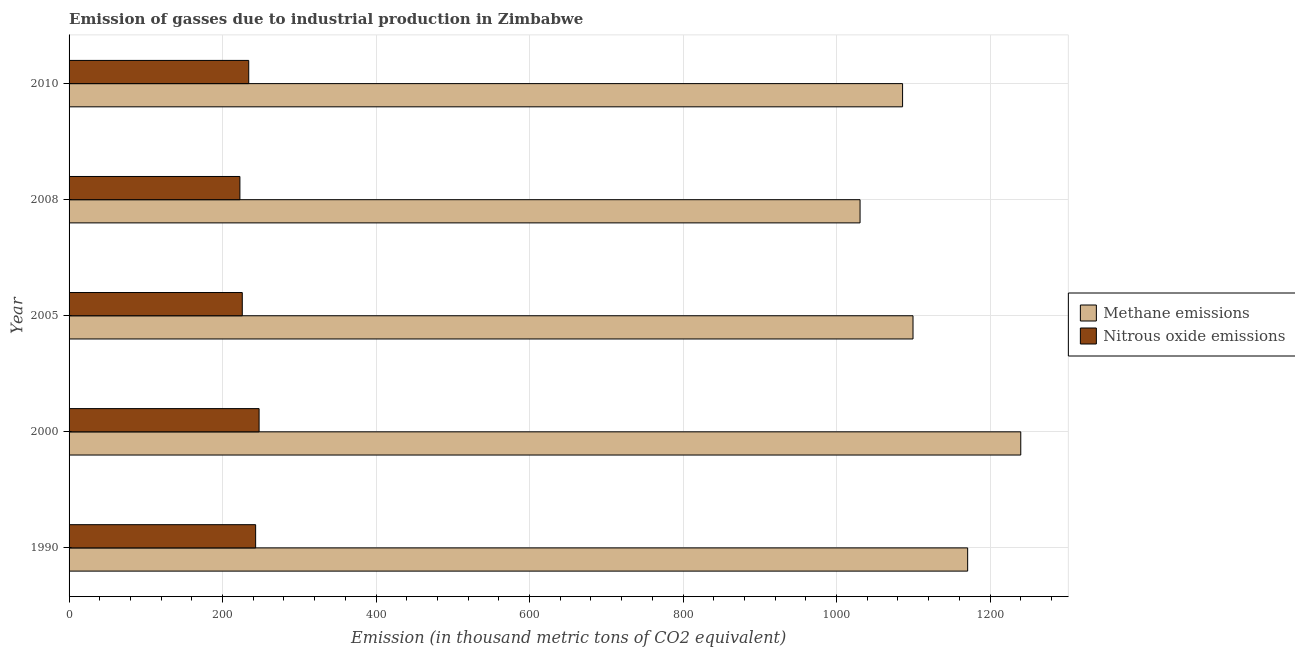How many groups of bars are there?
Keep it short and to the point. 5. Are the number of bars per tick equal to the number of legend labels?
Provide a succinct answer. Yes. Are the number of bars on each tick of the Y-axis equal?
Your answer should be very brief. Yes. What is the amount of methane emissions in 2010?
Your response must be concise. 1086.1. Across all years, what is the maximum amount of methane emissions?
Ensure brevity in your answer.  1240.1. Across all years, what is the minimum amount of nitrous oxide emissions?
Ensure brevity in your answer.  222.6. In which year was the amount of nitrous oxide emissions minimum?
Keep it short and to the point. 2008. What is the total amount of nitrous oxide emissions in the graph?
Provide a succinct answer. 1173.1. What is the difference between the amount of nitrous oxide emissions in 2008 and the amount of methane emissions in 1990?
Offer a terse response. -948.3. What is the average amount of methane emissions per year?
Provide a succinct answer. 1125.5. In the year 2005, what is the difference between the amount of nitrous oxide emissions and amount of methane emissions?
Provide a short and direct response. -874. What is the ratio of the amount of nitrous oxide emissions in 1990 to that in 2010?
Provide a short and direct response. 1.04. Is the amount of methane emissions in 2005 less than that in 2010?
Provide a succinct answer. No. What is the difference between the highest and the second highest amount of methane emissions?
Keep it short and to the point. 69.2. What is the difference between the highest and the lowest amount of nitrous oxide emissions?
Offer a terse response. 25. In how many years, is the amount of nitrous oxide emissions greater than the average amount of nitrous oxide emissions taken over all years?
Your answer should be compact. 2. What does the 2nd bar from the top in 2008 represents?
Ensure brevity in your answer.  Methane emissions. What does the 2nd bar from the bottom in 2005 represents?
Your response must be concise. Nitrous oxide emissions. How many bars are there?
Provide a short and direct response. 10. What is the difference between two consecutive major ticks on the X-axis?
Provide a short and direct response. 200. Are the values on the major ticks of X-axis written in scientific E-notation?
Offer a terse response. No. Does the graph contain grids?
Offer a very short reply. Yes. Where does the legend appear in the graph?
Offer a very short reply. Center right. How many legend labels are there?
Keep it short and to the point. 2. What is the title of the graph?
Your answer should be very brief. Emission of gasses due to industrial production in Zimbabwe. Does "Tetanus" appear as one of the legend labels in the graph?
Make the answer very short. No. What is the label or title of the X-axis?
Ensure brevity in your answer.  Emission (in thousand metric tons of CO2 equivalent). What is the Emission (in thousand metric tons of CO2 equivalent) of Methane emissions in 1990?
Your response must be concise. 1170.9. What is the Emission (in thousand metric tons of CO2 equivalent) in Nitrous oxide emissions in 1990?
Offer a terse response. 243.1. What is the Emission (in thousand metric tons of CO2 equivalent) in Methane emissions in 2000?
Offer a terse response. 1240.1. What is the Emission (in thousand metric tons of CO2 equivalent) in Nitrous oxide emissions in 2000?
Your answer should be compact. 247.6. What is the Emission (in thousand metric tons of CO2 equivalent) of Methane emissions in 2005?
Make the answer very short. 1099.7. What is the Emission (in thousand metric tons of CO2 equivalent) in Nitrous oxide emissions in 2005?
Ensure brevity in your answer.  225.7. What is the Emission (in thousand metric tons of CO2 equivalent) in Methane emissions in 2008?
Offer a terse response. 1030.7. What is the Emission (in thousand metric tons of CO2 equivalent) in Nitrous oxide emissions in 2008?
Your answer should be compact. 222.6. What is the Emission (in thousand metric tons of CO2 equivalent) of Methane emissions in 2010?
Your answer should be compact. 1086.1. What is the Emission (in thousand metric tons of CO2 equivalent) of Nitrous oxide emissions in 2010?
Your answer should be very brief. 234.1. Across all years, what is the maximum Emission (in thousand metric tons of CO2 equivalent) of Methane emissions?
Offer a terse response. 1240.1. Across all years, what is the maximum Emission (in thousand metric tons of CO2 equivalent) in Nitrous oxide emissions?
Give a very brief answer. 247.6. Across all years, what is the minimum Emission (in thousand metric tons of CO2 equivalent) in Methane emissions?
Offer a very short reply. 1030.7. Across all years, what is the minimum Emission (in thousand metric tons of CO2 equivalent) of Nitrous oxide emissions?
Offer a terse response. 222.6. What is the total Emission (in thousand metric tons of CO2 equivalent) of Methane emissions in the graph?
Offer a terse response. 5627.5. What is the total Emission (in thousand metric tons of CO2 equivalent) in Nitrous oxide emissions in the graph?
Ensure brevity in your answer.  1173.1. What is the difference between the Emission (in thousand metric tons of CO2 equivalent) in Methane emissions in 1990 and that in 2000?
Your response must be concise. -69.2. What is the difference between the Emission (in thousand metric tons of CO2 equivalent) in Nitrous oxide emissions in 1990 and that in 2000?
Make the answer very short. -4.5. What is the difference between the Emission (in thousand metric tons of CO2 equivalent) of Methane emissions in 1990 and that in 2005?
Offer a very short reply. 71.2. What is the difference between the Emission (in thousand metric tons of CO2 equivalent) in Nitrous oxide emissions in 1990 and that in 2005?
Offer a terse response. 17.4. What is the difference between the Emission (in thousand metric tons of CO2 equivalent) of Methane emissions in 1990 and that in 2008?
Provide a succinct answer. 140.2. What is the difference between the Emission (in thousand metric tons of CO2 equivalent) in Methane emissions in 1990 and that in 2010?
Provide a succinct answer. 84.8. What is the difference between the Emission (in thousand metric tons of CO2 equivalent) in Methane emissions in 2000 and that in 2005?
Your answer should be very brief. 140.4. What is the difference between the Emission (in thousand metric tons of CO2 equivalent) in Nitrous oxide emissions in 2000 and that in 2005?
Keep it short and to the point. 21.9. What is the difference between the Emission (in thousand metric tons of CO2 equivalent) of Methane emissions in 2000 and that in 2008?
Your response must be concise. 209.4. What is the difference between the Emission (in thousand metric tons of CO2 equivalent) in Methane emissions in 2000 and that in 2010?
Your answer should be very brief. 154. What is the difference between the Emission (in thousand metric tons of CO2 equivalent) in Nitrous oxide emissions in 2005 and that in 2008?
Keep it short and to the point. 3.1. What is the difference between the Emission (in thousand metric tons of CO2 equivalent) of Methane emissions in 2008 and that in 2010?
Offer a terse response. -55.4. What is the difference between the Emission (in thousand metric tons of CO2 equivalent) of Nitrous oxide emissions in 2008 and that in 2010?
Make the answer very short. -11.5. What is the difference between the Emission (in thousand metric tons of CO2 equivalent) in Methane emissions in 1990 and the Emission (in thousand metric tons of CO2 equivalent) in Nitrous oxide emissions in 2000?
Give a very brief answer. 923.3. What is the difference between the Emission (in thousand metric tons of CO2 equivalent) in Methane emissions in 1990 and the Emission (in thousand metric tons of CO2 equivalent) in Nitrous oxide emissions in 2005?
Ensure brevity in your answer.  945.2. What is the difference between the Emission (in thousand metric tons of CO2 equivalent) of Methane emissions in 1990 and the Emission (in thousand metric tons of CO2 equivalent) of Nitrous oxide emissions in 2008?
Offer a very short reply. 948.3. What is the difference between the Emission (in thousand metric tons of CO2 equivalent) in Methane emissions in 1990 and the Emission (in thousand metric tons of CO2 equivalent) in Nitrous oxide emissions in 2010?
Your answer should be compact. 936.8. What is the difference between the Emission (in thousand metric tons of CO2 equivalent) in Methane emissions in 2000 and the Emission (in thousand metric tons of CO2 equivalent) in Nitrous oxide emissions in 2005?
Give a very brief answer. 1014.4. What is the difference between the Emission (in thousand metric tons of CO2 equivalent) in Methane emissions in 2000 and the Emission (in thousand metric tons of CO2 equivalent) in Nitrous oxide emissions in 2008?
Ensure brevity in your answer.  1017.5. What is the difference between the Emission (in thousand metric tons of CO2 equivalent) in Methane emissions in 2000 and the Emission (in thousand metric tons of CO2 equivalent) in Nitrous oxide emissions in 2010?
Your response must be concise. 1006. What is the difference between the Emission (in thousand metric tons of CO2 equivalent) in Methane emissions in 2005 and the Emission (in thousand metric tons of CO2 equivalent) in Nitrous oxide emissions in 2008?
Provide a succinct answer. 877.1. What is the difference between the Emission (in thousand metric tons of CO2 equivalent) in Methane emissions in 2005 and the Emission (in thousand metric tons of CO2 equivalent) in Nitrous oxide emissions in 2010?
Provide a succinct answer. 865.6. What is the difference between the Emission (in thousand metric tons of CO2 equivalent) of Methane emissions in 2008 and the Emission (in thousand metric tons of CO2 equivalent) of Nitrous oxide emissions in 2010?
Keep it short and to the point. 796.6. What is the average Emission (in thousand metric tons of CO2 equivalent) of Methane emissions per year?
Give a very brief answer. 1125.5. What is the average Emission (in thousand metric tons of CO2 equivalent) of Nitrous oxide emissions per year?
Offer a very short reply. 234.62. In the year 1990, what is the difference between the Emission (in thousand metric tons of CO2 equivalent) of Methane emissions and Emission (in thousand metric tons of CO2 equivalent) of Nitrous oxide emissions?
Your answer should be very brief. 927.8. In the year 2000, what is the difference between the Emission (in thousand metric tons of CO2 equivalent) in Methane emissions and Emission (in thousand metric tons of CO2 equivalent) in Nitrous oxide emissions?
Provide a short and direct response. 992.5. In the year 2005, what is the difference between the Emission (in thousand metric tons of CO2 equivalent) in Methane emissions and Emission (in thousand metric tons of CO2 equivalent) in Nitrous oxide emissions?
Make the answer very short. 874. In the year 2008, what is the difference between the Emission (in thousand metric tons of CO2 equivalent) of Methane emissions and Emission (in thousand metric tons of CO2 equivalent) of Nitrous oxide emissions?
Your answer should be very brief. 808.1. In the year 2010, what is the difference between the Emission (in thousand metric tons of CO2 equivalent) in Methane emissions and Emission (in thousand metric tons of CO2 equivalent) in Nitrous oxide emissions?
Your answer should be very brief. 852. What is the ratio of the Emission (in thousand metric tons of CO2 equivalent) in Methane emissions in 1990 to that in 2000?
Ensure brevity in your answer.  0.94. What is the ratio of the Emission (in thousand metric tons of CO2 equivalent) of Nitrous oxide emissions in 1990 to that in 2000?
Offer a very short reply. 0.98. What is the ratio of the Emission (in thousand metric tons of CO2 equivalent) in Methane emissions in 1990 to that in 2005?
Keep it short and to the point. 1.06. What is the ratio of the Emission (in thousand metric tons of CO2 equivalent) of Nitrous oxide emissions in 1990 to that in 2005?
Provide a short and direct response. 1.08. What is the ratio of the Emission (in thousand metric tons of CO2 equivalent) of Methane emissions in 1990 to that in 2008?
Provide a short and direct response. 1.14. What is the ratio of the Emission (in thousand metric tons of CO2 equivalent) of Nitrous oxide emissions in 1990 to that in 2008?
Your answer should be very brief. 1.09. What is the ratio of the Emission (in thousand metric tons of CO2 equivalent) in Methane emissions in 1990 to that in 2010?
Keep it short and to the point. 1.08. What is the ratio of the Emission (in thousand metric tons of CO2 equivalent) in Nitrous oxide emissions in 1990 to that in 2010?
Ensure brevity in your answer.  1.04. What is the ratio of the Emission (in thousand metric tons of CO2 equivalent) in Methane emissions in 2000 to that in 2005?
Your answer should be compact. 1.13. What is the ratio of the Emission (in thousand metric tons of CO2 equivalent) in Nitrous oxide emissions in 2000 to that in 2005?
Your answer should be compact. 1.1. What is the ratio of the Emission (in thousand metric tons of CO2 equivalent) in Methane emissions in 2000 to that in 2008?
Your answer should be very brief. 1.2. What is the ratio of the Emission (in thousand metric tons of CO2 equivalent) of Nitrous oxide emissions in 2000 to that in 2008?
Your answer should be very brief. 1.11. What is the ratio of the Emission (in thousand metric tons of CO2 equivalent) in Methane emissions in 2000 to that in 2010?
Your answer should be very brief. 1.14. What is the ratio of the Emission (in thousand metric tons of CO2 equivalent) of Nitrous oxide emissions in 2000 to that in 2010?
Offer a very short reply. 1.06. What is the ratio of the Emission (in thousand metric tons of CO2 equivalent) in Methane emissions in 2005 to that in 2008?
Ensure brevity in your answer.  1.07. What is the ratio of the Emission (in thousand metric tons of CO2 equivalent) of Nitrous oxide emissions in 2005 to that in 2008?
Your answer should be very brief. 1.01. What is the ratio of the Emission (in thousand metric tons of CO2 equivalent) of Methane emissions in 2005 to that in 2010?
Make the answer very short. 1.01. What is the ratio of the Emission (in thousand metric tons of CO2 equivalent) in Nitrous oxide emissions in 2005 to that in 2010?
Your answer should be very brief. 0.96. What is the ratio of the Emission (in thousand metric tons of CO2 equivalent) in Methane emissions in 2008 to that in 2010?
Make the answer very short. 0.95. What is the ratio of the Emission (in thousand metric tons of CO2 equivalent) in Nitrous oxide emissions in 2008 to that in 2010?
Provide a succinct answer. 0.95. What is the difference between the highest and the second highest Emission (in thousand metric tons of CO2 equivalent) in Methane emissions?
Your answer should be compact. 69.2. What is the difference between the highest and the second highest Emission (in thousand metric tons of CO2 equivalent) in Nitrous oxide emissions?
Your answer should be very brief. 4.5. What is the difference between the highest and the lowest Emission (in thousand metric tons of CO2 equivalent) in Methane emissions?
Your answer should be compact. 209.4. 